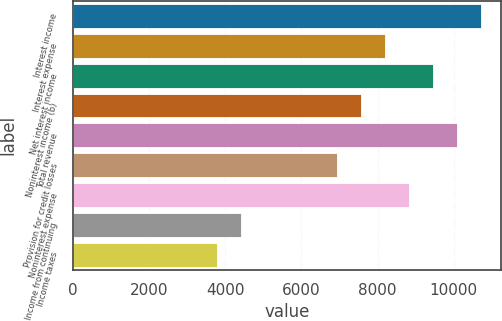Convert chart. <chart><loc_0><loc_0><loc_500><loc_500><bar_chart><fcel>Interest income<fcel>Interest expense<fcel>Net interest income<fcel>Noninterest income (b)<fcel>Total revenue<fcel>Provision for credit losses<fcel>Noninterest expense<fcel>Income from continuing<fcel>Income taxes<nl><fcel>10711.5<fcel>8191.25<fcel>9451.39<fcel>7561.18<fcel>10081.5<fcel>6931.11<fcel>8821.32<fcel>4410.83<fcel>3780.76<nl></chart> 